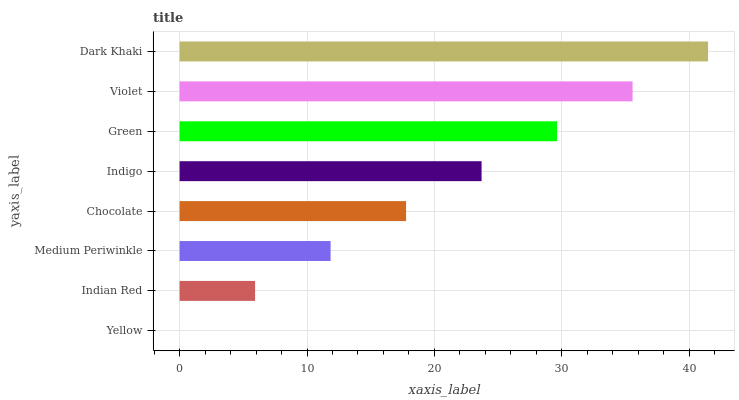Is Yellow the minimum?
Answer yes or no. Yes. Is Dark Khaki the maximum?
Answer yes or no. Yes. Is Indian Red the minimum?
Answer yes or no. No. Is Indian Red the maximum?
Answer yes or no. No. Is Indian Red greater than Yellow?
Answer yes or no. Yes. Is Yellow less than Indian Red?
Answer yes or no. Yes. Is Yellow greater than Indian Red?
Answer yes or no. No. Is Indian Red less than Yellow?
Answer yes or no. No. Is Indigo the high median?
Answer yes or no. Yes. Is Chocolate the low median?
Answer yes or no. Yes. Is Indian Red the high median?
Answer yes or no. No. Is Medium Periwinkle the low median?
Answer yes or no. No. 